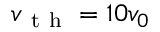<formula> <loc_0><loc_0><loc_500><loc_500>v _ { t h } = 1 0 v _ { 0 }</formula> 